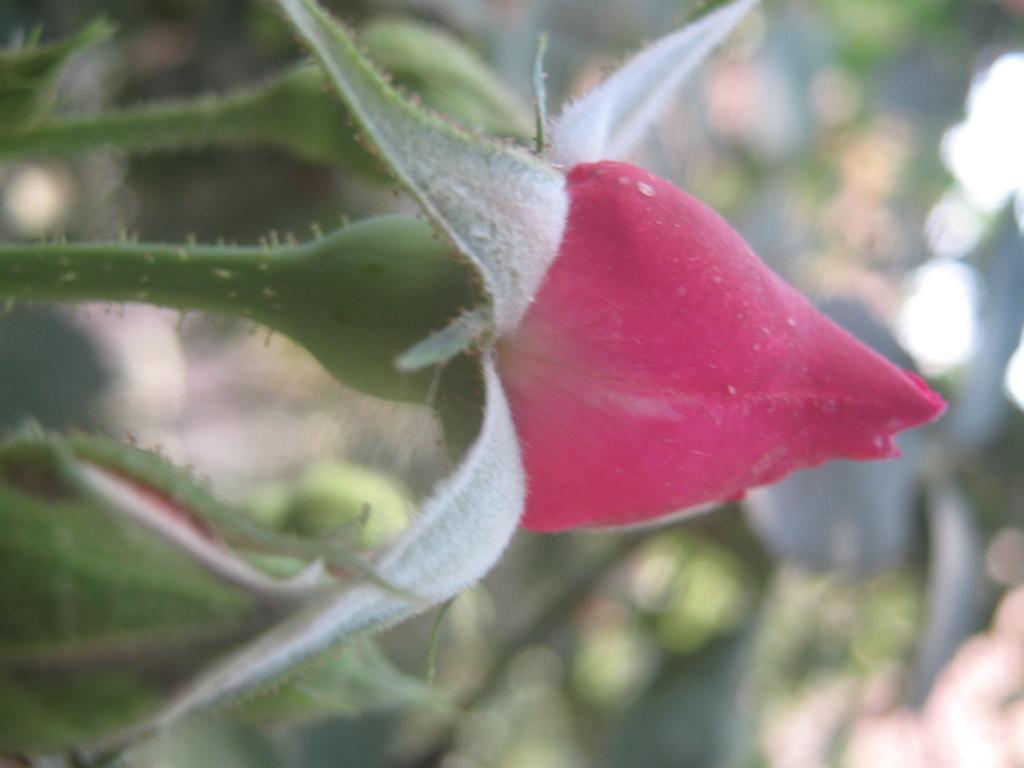Could you give a brief overview of what you see in this image? In this image we can see the buds and also the stems and the background is blurred. 